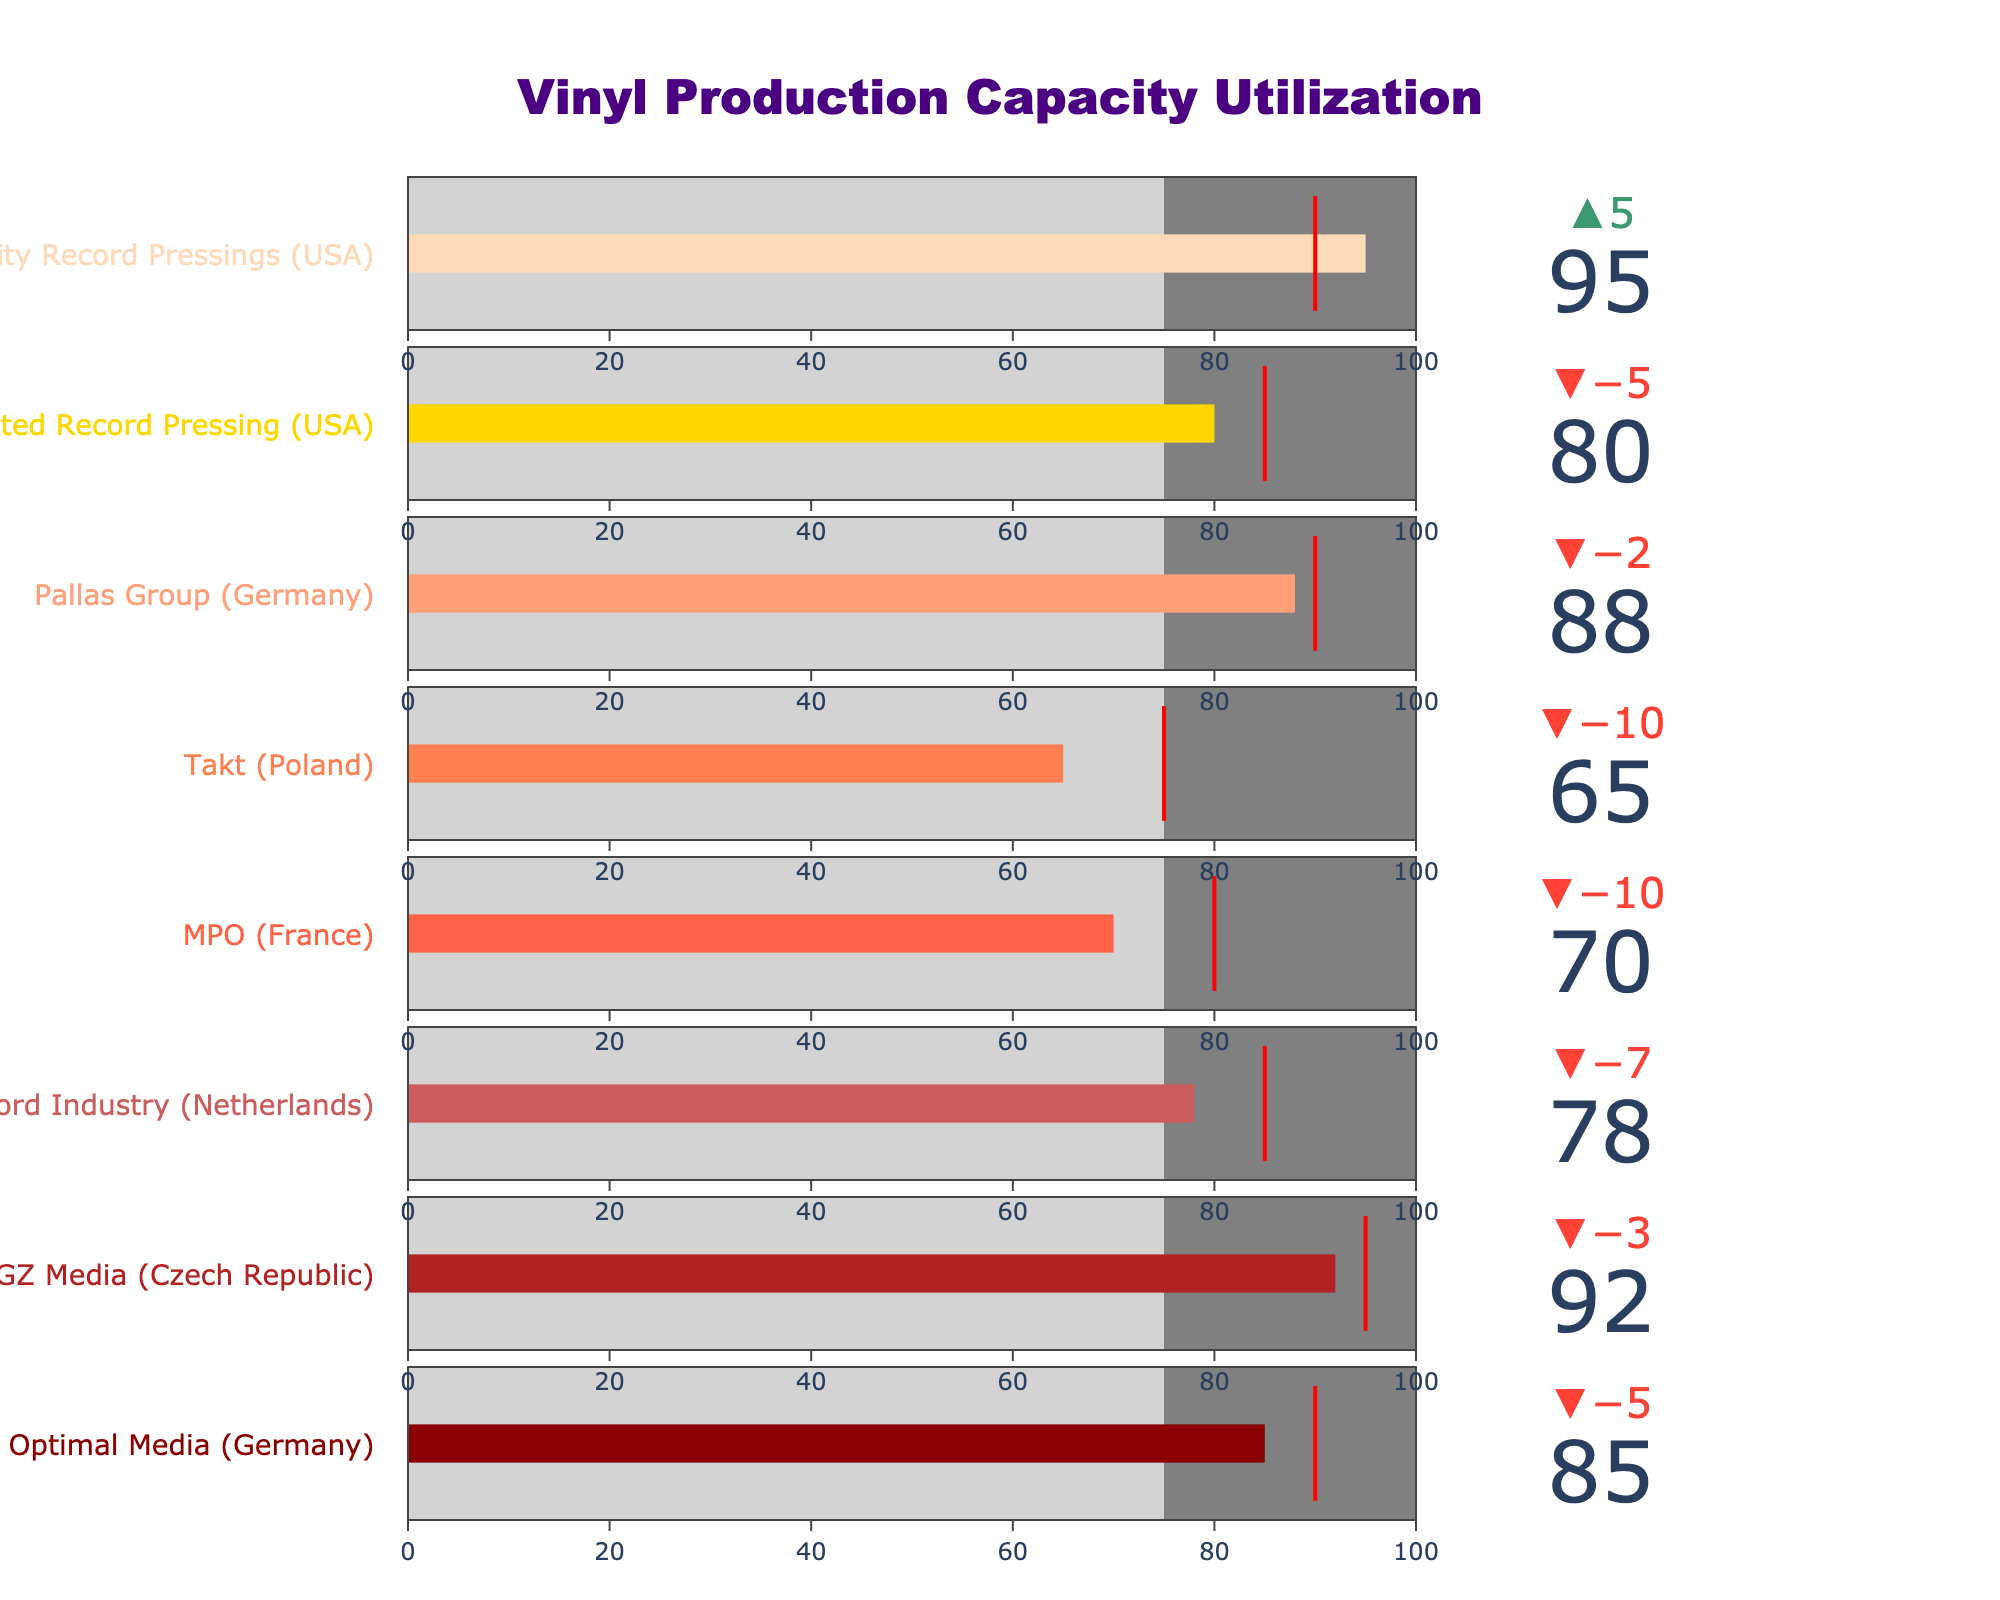What's the title of the figure? The title is typically located at the top of the figure. In this case, it reads "Vinyl Production Capacity Utilization".
Answer: Vinyl Production Capacity Utilization Which plant has the highest actual production capacity utilization? By looking at the bar chart values, Quality Record Pressings (USA) has the highest actual production capacity utilization of 95%.
Answer: Quality Record Pressings (USA) What is the target production capacity for MPO (France)? The target value for each plant is marked with a red line on the bullet chart. For MPO (France), it is indicated at 80%.
Answer: 80% How does the actual production capacity of Takt (Poland) compare to the industry average? The industry average value is marked by a grey area extending up to 75%. Takt's actual value is 65%, which is below the industry average.
Answer: Below What is the difference between the actual and target production capacities for Optimal Media (Germany)? The actual value is 85% and the target is 90%. The difference is 90 - 85 = 5%.
Answer: 5% Which plant exceeds its target production capacity utilization? A plant exceeds its target if the actual value (dark bar) surpasses the red line (target). Quality Record Pressings (USA) has an actual value of 95%, which is above its target of 90%.
Answer: Quality Record Pressings (USA) What's the range of values for the axis in the figure? The axis range, covering from 0 to the Maximum Capacity, is constant for each plant and spans from 0 to 100.
Answer: 0 to 100 How many plants are included in the figure? By counting the number of bullet charts or titles, there are 8 different pressing plants depicted in the figure.
Answer: 8 Which plant has the most significant difference between its actual and target production capacities? By comparing the differences across plants: Optimal Media (5), GZ Media (3), Record Industry (7), MPO (10), Takt (10), Pallas Group (2), United Record Pressing (5), and Quality Record Pressings (-5), MPO and Takt both have the largest difference at 10%.
Answer: MPO and Takt (tie) Which plants have actual utilization equal or above their target? By identifying plants where the actual (dark bar) reaches the red line (target): Quality Record Pressings (95 actual vs. 90 target).
Answer: Quality Record Pressings 